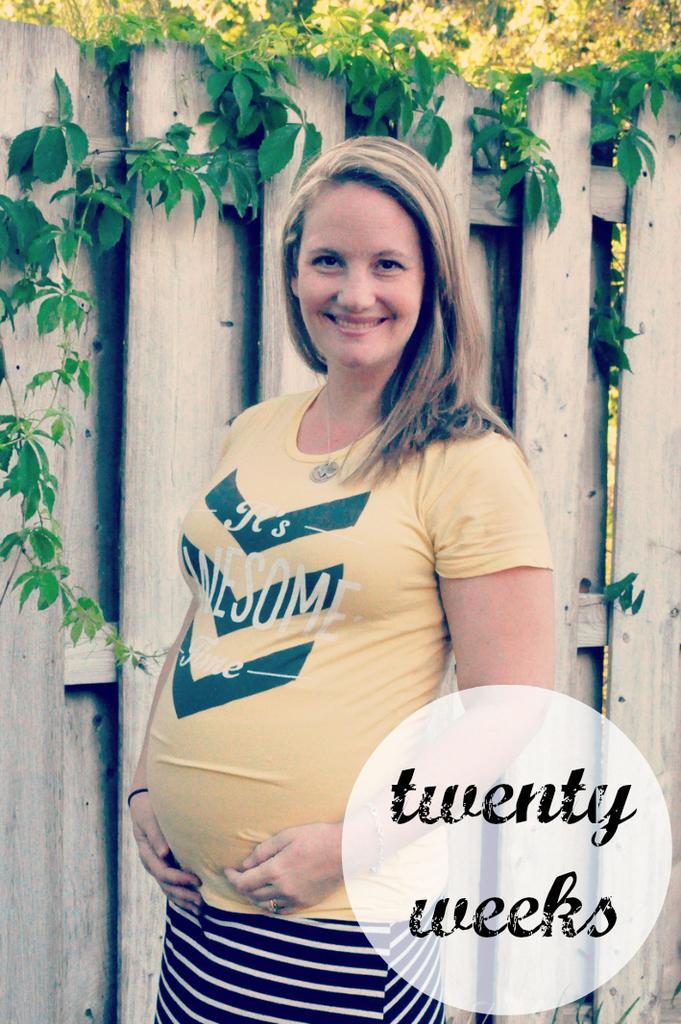In one or two sentences, can you explain what this image depicts? In the picture I can see a woman wearing a yellow color T-shirt and there is a smile on her face. I can see the wooden fencing and there are green leaves at the top of the picture. 